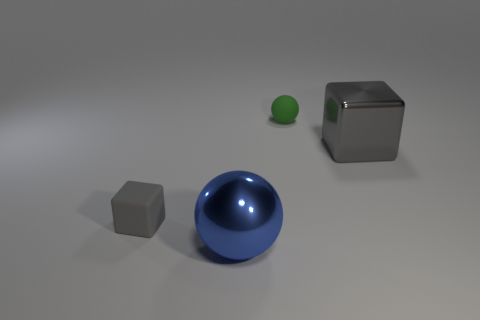There is a metallic cube that is the same color as the rubber block; what size is it?
Provide a short and direct response. Large. There is a cube that is on the right side of the green object; is it the same size as the small gray rubber cube?
Provide a short and direct response. No. What number of other things are there of the same size as the metallic block?
Ensure brevity in your answer.  1. What is the color of the tiny matte block?
Your answer should be compact. Gray. There is a big object behind the big metal ball; what is its material?
Your answer should be very brief. Metal. Are there the same number of tiny rubber objects behind the small rubber cube and big gray cylinders?
Ensure brevity in your answer.  No. Is the gray rubber thing the same shape as the big gray shiny object?
Offer a terse response. Yes. Are there any other things that have the same color as the big metal cube?
Your answer should be compact. Yes. There is a thing that is behind the big blue metal ball and on the left side of the green thing; what shape is it?
Your answer should be compact. Cube. Are there the same number of tiny green matte things on the left side of the small green ball and blocks behind the big cube?
Ensure brevity in your answer.  Yes. 